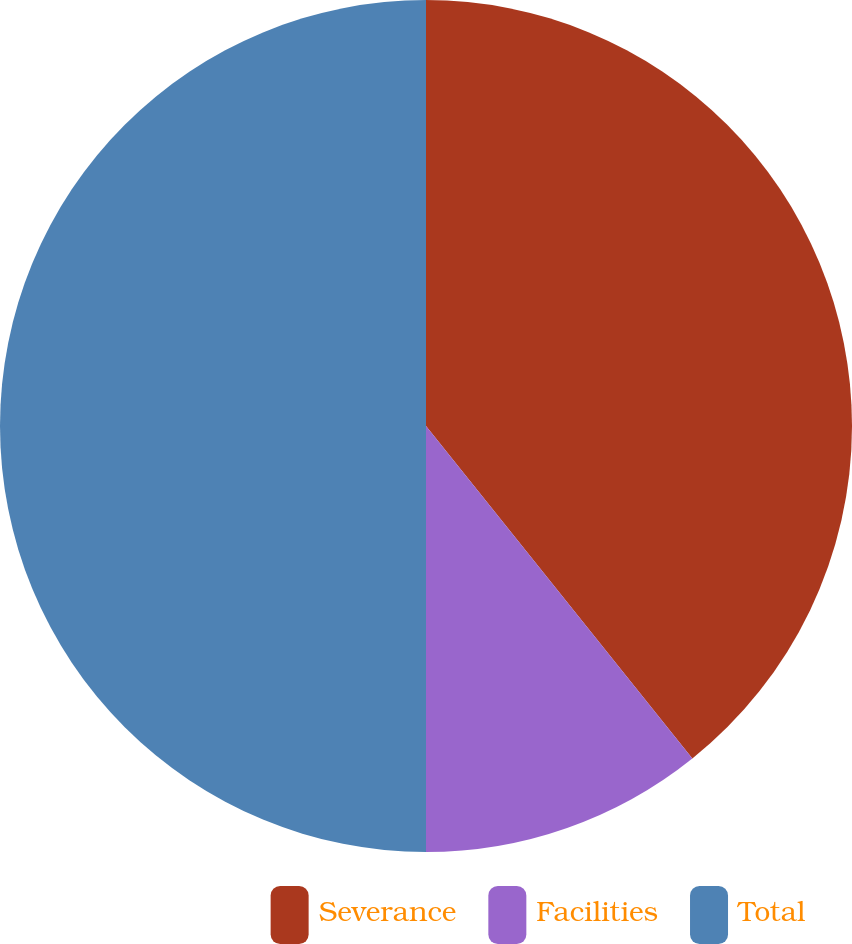Convert chart to OTSL. <chart><loc_0><loc_0><loc_500><loc_500><pie_chart><fcel>Severance<fcel>Facilities<fcel>Total<nl><fcel>39.25%<fcel>10.75%<fcel>50.0%<nl></chart> 